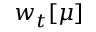Convert formula to latex. <formula><loc_0><loc_0><loc_500><loc_500>w _ { t } [ \mu ]</formula> 